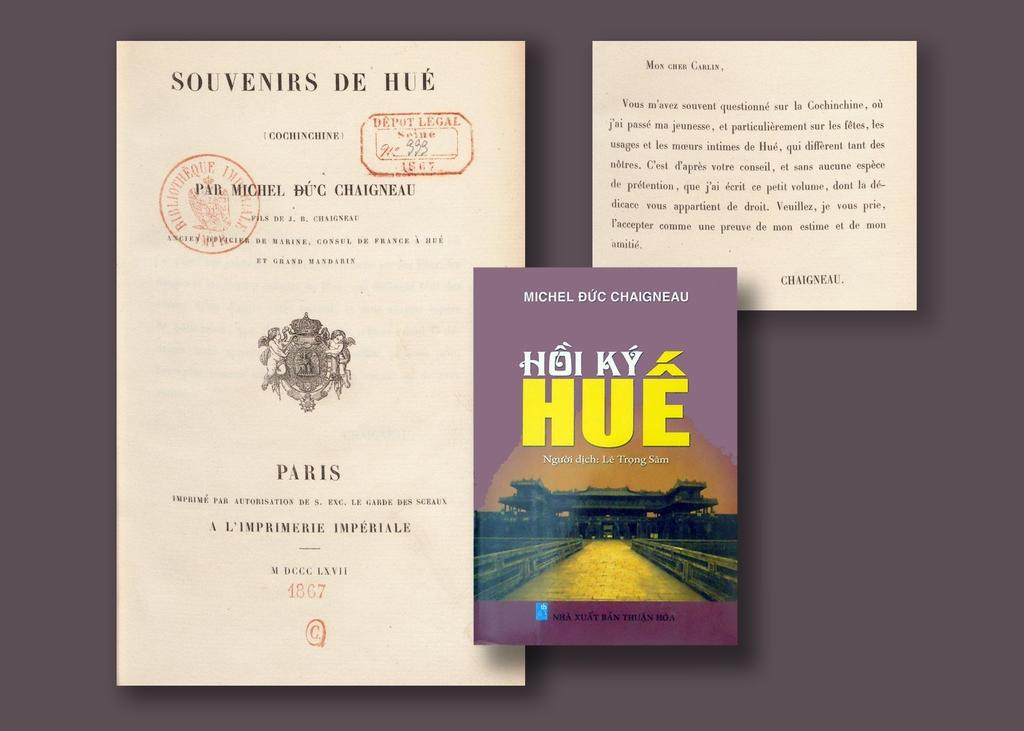<image>
Render a clear and concise summary of the photo. Book resting on a table that is titled "Hoi Ky Hue". 